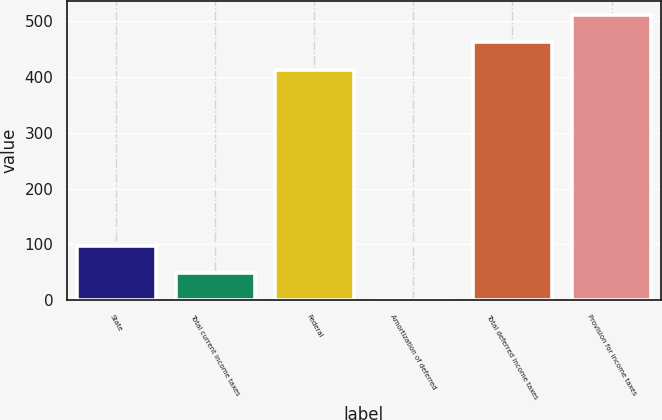<chart> <loc_0><loc_0><loc_500><loc_500><bar_chart><fcel>State<fcel>Total current income taxes<fcel>Federal<fcel>Amortization of deferred<fcel>Total deferred income taxes<fcel>Provision for income taxes<nl><fcel>98<fcel>49.5<fcel>413<fcel>1<fcel>462<fcel>510.5<nl></chart> 